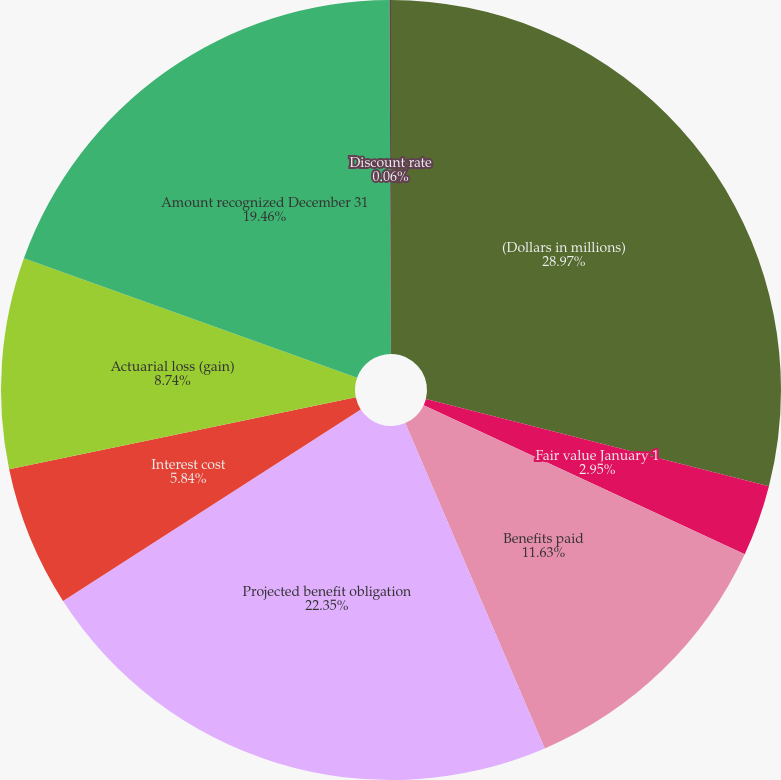<chart> <loc_0><loc_0><loc_500><loc_500><pie_chart><fcel>(Dollars in millions)<fcel>Fair value January 1<fcel>Benefits paid<fcel>Projected benefit obligation<fcel>Interest cost<fcel>Actuarial loss (gain)<fcel>Amount recognized December 31<fcel>Discount rate<nl><fcel>28.97%<fcel>2.95%<fcel>11.63%<fcel>22.35%<fcel>5.84%<fcel>8.74%<fcel>19.46%<fcel>0.06%<nl></chart> 